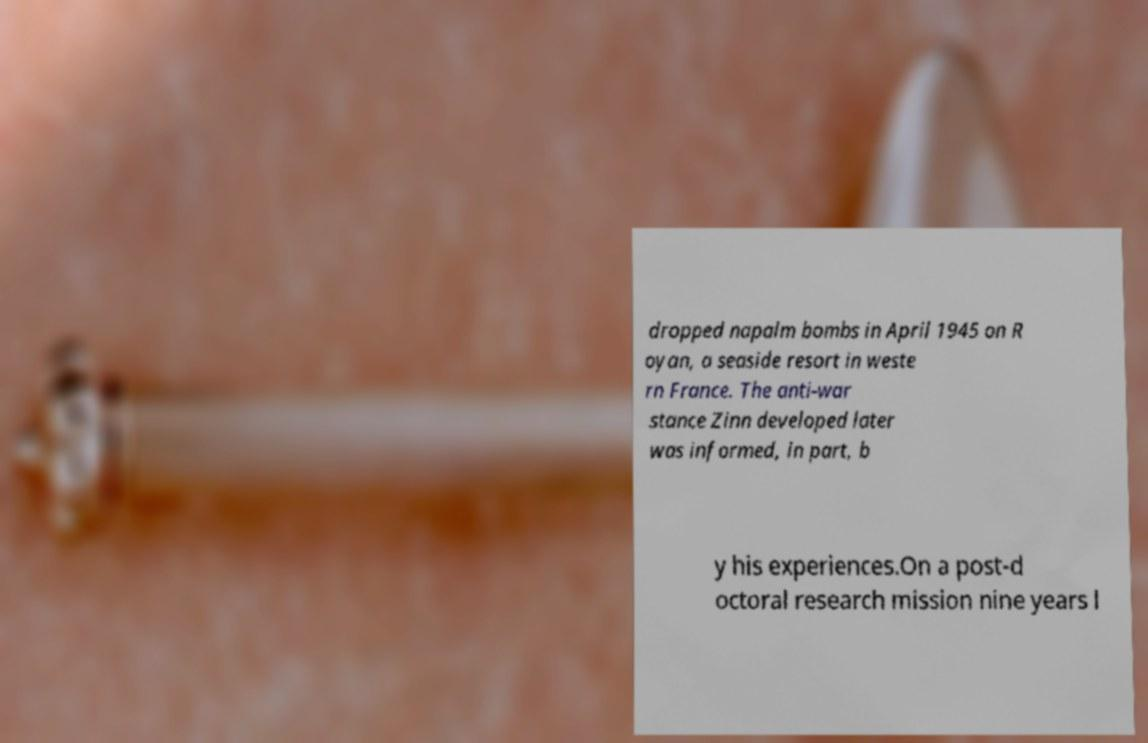Could you assist in decoding the text presented in this image and type it out clearly? dropped napalm bombs in April 1945 on R oyan, a seaside resort in weste rn France. The anti-war stance Zinn developed later was informed, in part, b y his experiences.On a post-d octoral research mission nine years l 